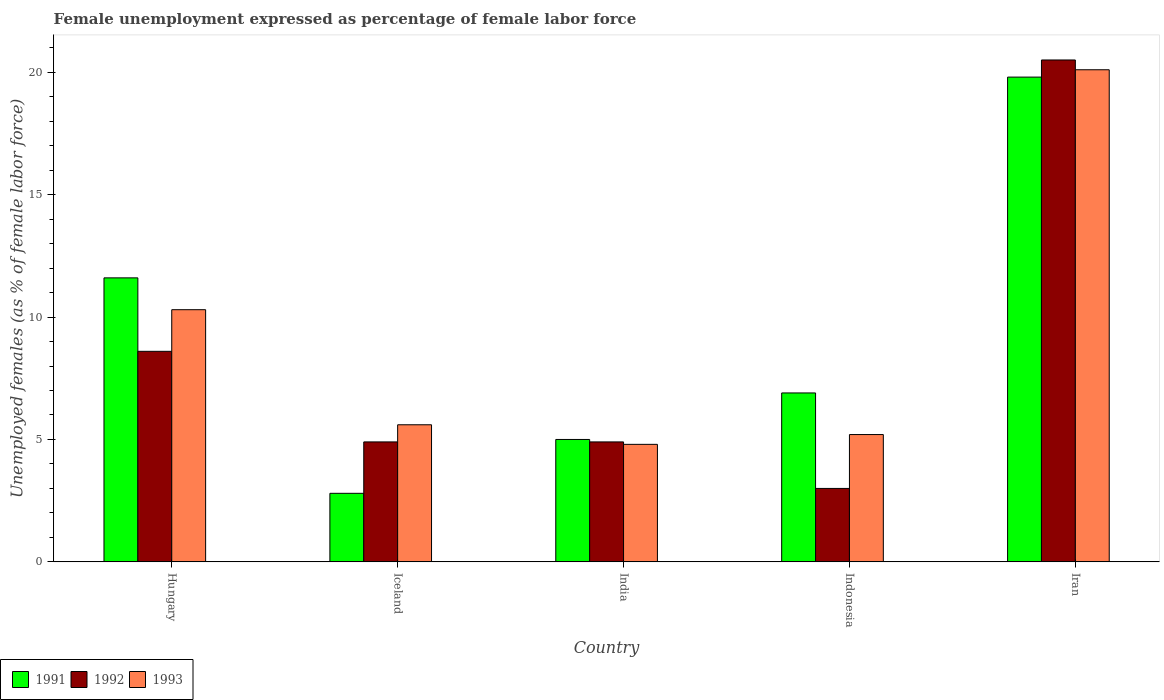How many groups of bars are there?
Your answer should be very brief. 5. How many bars are there on the 1st tick from the left?
Your response must be concise. 3. How many bars are there on the 3rd tick from the right?
Keep it short and to the point. 3. What is the label of the 5th group of bars from the left?
Offer a terse response. Iran. What is the unemployment in females in in 1992 in Hungary?
Your answer should be very brief. 8.6. Across all countries, what is the maximum unemployment in females in in 1991?
Your answer should be very brief. 19.8. Across all countries, what is the minimum unemployment in females in in 1993?
Offer a very short reply. 4.8. In which country was the unemployment in females in in 1992 maximum?
Offer a terse response. Iran. What is the total unemployment in females in in 1991 in the graph?
Your answer should be very brief. 46.1. What is the difference between the unemployment in females in in 1992 in India and that in Indonesia?
Offer a very short reply. 1.9. What is the difference between the unemployment in females in in 1992 in India and the unemployment in females in in 1991 in Hungary?
Your answer should be compact. -6.7. What is the average unemployment in females in in 1992 per country?
Offer a very short reply. 8.38. What is the difference between the unemployment in females in of/in 1991 and unemployment in females in of/in 1992 in Hungary?
Give a very brief answer. 3. In how many countries, is the unemployment in females in in 1992 greater than 3 %?
Ensure brevity in your answer.  4. What is the ratio of the unemployment in females in in 1992 in Iceland to that in Iran?
Provide a succinct answer. 0.24. Is the difference between the unemployment in females in in 1991 in Hungary and India greater than the difference between the unemployment in females in in 1992 in Hungary and India?
Your answer should be very brief. Yes. What is the difference between the highest and the second highest unemployment in females in in 1993?
Your response must be concise. -9.8. What is the difference between the highest and the lowest unemployment in females in in 1992?
Your response must be concise. 17.5. In how many countries, is the unemployment in females in in 1991 greater than the average unemployment in females in in 1991 taken over all countries?
Ensure brevity in your answer.  2. How many countries are there in the graph?
Offer a very short reply. 5. Are the values on the major ticks of Y-axis written in scientific E-notation?
Make the answer very short. No. Does the graph contain any zero values?
Provide a succinct answer. No. How many legend labels are there?
Your answer should be very brief. 3. How are the legend labels stacked?
Keep it short and to the point. Horizontal. What is the title of the graph?
Offer a terse response. Female unemployment expressed as percentage of female labor force. What is the label or title of the Y-axis?
Your response must be concise. Unemployed females (as % of female labor force). What is the Unemployed females (as % of female labor force) in 1991 in Hungary?
Your answer should be very brief. 11.6. What is the Unemployed females (as % of female labor force) in 1992 in Hungary?
Make the answer very short. 8.6. What is the Unemployed females (as % of female labor force) of 1993 in Hungary?
Provide a succinct answer. 10.3. What is the Unemployed females (as % of female labor force) of 1991 in Iceland?
Your answer should be very brief. 2.8. What is the Unemployed females (as % of female labor force) in 1992 in Iceland?
Offer a terse response. 4.9. What is the Unemployed females (as % of female labor force) in 1993 in Iceland?
Keep it short and to the point. 5.6. What is the Unemployed females (as % of female labor force) in 1992 in India?
Offer a terse response. 4.9. What is the Unemployed females (as % of female labor force) of 1993 in India?
Your answer should be compact. 4.8. What is the Unemployed females (as % of female labor force) of 1991 in Indonesia?
Offer a terse response. 6.9. What is the Unemployed females (as % of female labor force) in 1992 in Indonesia?
Your answer should be very brief. 3. What is the Unemployed females (as % of female labor force) in 1993 in Indonesia?
Offer a terse response. 5.2. What is the Unemployed females (as % of female labor force) in 1991 in Iran?
Your answer should be very brief. 19.8. What is the Unemployed females (as % of female labor force) of 1992 in Iran?
Give a very brief answer. 20.5. What is the Unemployed females (as % of female labor force) in 1993 in Iran?
Ensure brevity in your answer.  20.1. Across all countries, what is the maximum Unemployed females (as % of female labor force) of 1991?
Make the answer very short. 19.8. Across all countries, what is the maximum Unemployed females (as % of female labor force) in 1992?
Your answer should be very brief. 20.5. Across all countries, what is the maximum Unemployed females (as % of female labor force) of 1993?
Make the answer very short. 20.1. Across all countries, what is the minimum Unemployed females (as % of female labor force) of 1991?
Your response must be concise. 2.8. Across all countries, what is the minimum Unemployed females (as % of female labor force) in 1993?
Offer a terse response. 4.8. What is the total Unemployed females (as % of female labor force) in 1991 in the graph?
Keep it short and to the point. 46.1. What is the total Unemployed females (as % of female labor force) of 1992 in the graph?
Make the answer very short. 41.9. What is the total Unemployed females (as % of female labor force) in 1993 in the graph?
Provide a succinct answer. 46. What is the difference between the Unemployed females (as % of female labor force) of 1992 in Hungary and that in Iceland?
Ensure brevity in your answer.  3.7. What is the difference between the Unemployed females (as % of female labor force) in 1993 in Hungary and that in Iceland?
Offer a very short reply. 4.7. What is the difference between the Unemployed females (as % of female labor force) of 1991 in Hungary and that in India?
Offer a very short reply. 6.6. What is the difference between the Unemployed females (as % of female labor force) of 1991 in Hungary and that in Iran?
Provide a short and direct response. -8.2. What is the difference between the Unemployed females (as % of female labor force) in 1992 in Hungary and that in Iran?
Provide a succinct answer. -11.9. What is the difference between the Unemployed females (as % of female labor force) of 1993 in Hungary and that in Iran?
Provide a succinct answer. -9.8. What is the difference between the Unemployed females (as % of female labor force) of 1991 in Iceland and that in India?
Offer a terse response. -2.2. What is the difference between the Unemployed females (as % of female labor force) in 1993 in Iceland and that in India?
Ensure brevity in your answer.  0.8. What is the difference between the Unemployed females (as % of female labor force) of 1991 in Iceland and that in Indonesia?
Provide a short and direct response. -4.1. What is the difference between the Unemployed females (as % of female labor force) in 1991 in Iceland and that in Iran?
Ensure brevity in your answer.  -17. What is the difference between the Unemployed females (as % of female labor force) in 1992 in Iceland and that in Iran?
Your answer should be very brief. -15.6. What is the difference between the Unemployed females (as % of female labor force) in 1993 in Iceland and that in Iran?
Your response must be concise. -14.5. What is the difference between the Unemployed females (as % of female labor force) in 1992 in India and that in Indonesia?
Your answer should be compact. 1.9. What is the difference between the Unemployed females (as % of female labor force) of 1991 in India and that in Iran?
Keep it short and to the point. -14.8. What is the difference between the Unemployed females (as % of female labor force) in 1992 in India and that in Iran?
Offer a terse response. -15.6. What is the difference between the Unemployed females (as % of female labor force) of 1993 in India and that in Iran?
Your response must be concise. -15.3. What is the difference between the Unemployed females (as % of female labor force) of 1991 in Indonesia and that in Iran?
Offer a terse response. -12.9. What is the difference between the Unemployed females (as % of female labor force) of 1992 in Indonesia and that in Iran?
Offer a terse response. -17.5. What is the difference between the Unemployed females (as % of female labor force) of 1993 in Indonesia and that in Iran?
Give a very brief answer. -14.9. What is the difference between the Unemployed females (as % of female labor force) in 1992 in Hungary and the Unemployed females (as % of female labor force) in 1993 in Iceland?
Give a very brief answer. 3. What is the difference between the Unemployed females (as % of female labor force) in 1991 in Hungary and the Unemployed females (as % of female labor force) in 1992 in India?
Your response must be concise. 6.7. What is the difference between the Unemployed females (as % of female labor force) of 1991 in Hungary and the Unemployed females (as % of female labor force) of 1993 in India?
Ensure brevity in your answer.  6.8. What is the difference between the Unemployed females (as % of female labor force) in 1992 in Hungary and the Unemployed females (as % of female labor force) in 1993 in India?
Your response must be concise. 3.8. What is the difference between the Unemployed females (as % of female labor force) of 1991 in Hungary and the Unemployed females (as % of female labor force) of 1992 in Indonesia?
Make the answer very short. 8.6. What is the difference between the Unemployed females (as % of female labor force) in 1992 in Hungary and the Unemployed females (as % of female labor force) in 1993 in Indonesia?
Keep it short and to the point. 3.4. What is the difference between the Unemployed females (as % of female labor force) of 1991 in Hungary and the Unemployed females (as % of female labor force) of 1992 in Iran?
Your answer should be very brief. -8.9. What is the difference between the Unemployed females (as % of female labor force) in 1991 in Hungary and the Unemployed females (as % of female labor force) in 1993 in Iran?
Your answer should be very brief. -8.5. What is the difference between the Unemployed females (as % of female labor force) in 1991 in Iceland and the Unemployed females (as % of female labor force) in 1992 in India?
Offer a very short reply. -2.1. What is the difference between the Unemployed females (as % of female labor force) in 1991 in Iceland and the Unemployed females (as % of female labor force) in 1992 in Indonesia?
Offer a terse response. -0.2. What is the difference between the Unemployed females (as % of female labor force) of 1991 in Iceland and the Unemployed females (as % of female labor force) of 1993 in Indonesia?
Provide a succinct answer. -2.4. What is the difference between the Unemployed females (as % of female labor force) in 1992 in Iceland and the Unemployed females (as % of female labor force) in 1993 in Indonesia?
Your answer should be compact. -0.3. What is the difference between the Unemployed females (as % of female labor force) of 1991 in Iceland and the Unemployed females (as % of female labor force) of 1992 in Iran?
Your answer should be very brief. -17.7. What is the difference between the Unemployed females (as % of female labor force) in 1991 in Iceland and the Unemployed females (as % of female labor force) in 1993 in Iran?
Provide a short and direct response. -17.3. What is the difference between the Unemployed females (as % of female labor force) in 1992 in Iceland and the Unemployed females (as % of female labor force) in 1993 in Iran?
Your response must be concise. -15.2. What is the difference between the Unemployed females (as % of female labor force) in 1991 in India and the Unemployed females (as % of female labor force) in 1992 in Indonesia?
Give a very brief answer. 2. What is the difference between the Unemployed females (as % of female labor force) in 1991 in India and the Unemployed females (as % of female labor force) in 1993 in Indonesia?
Give a very brief answer. -0.2. What is the difference between the Unemployed females (as % of female labor force) in 1991 in India and the Unemployed females (as % of female labor force) in 1992 in Iran?
Your response must be concise. -15.5. What is the difference between the Unemployed females (as % of female labor force) of 1991 in India and the Unemployed females (as % of female labor force) of 1993 in Iran?
Provide a succinct answer. -15.1. What is the difference between the Unemployed females (as % of female labor force) in 1992 in India and the Unemployed females (as % of female labor force) in 1993 in Iran?
Make the answer very short. -15.2. What is the difference between the Unemployed females (as % of female labor force) in 1992 in Indonesia and the Unemployed females (as % of female labor force) in 1993 in Iran?
Offer a terse response. -17.1. What is the average Unemployed females (as % of female labor force) in 1991 per country?
Your response must be concise. 9.22. What is the average Unemployed females (as % of female labor force) in 1992 per country?
Make the answer very short. 8.38. What is the difference between the Unemployed females (as % of female labor force) in 1992 and Unemployed females (as % of female labor force) in 1993 in Hungary?
Offer a very short reply. -1.7. What is the difference between the Unemployed females (as % of female labor force) of 1991 and Unemployed females (as % of female labor force) of 1992 in Iceland?
Keep it short and to the point. -2.1. What is the difference between the Unemployed females (as % of female labor force) of 1992 and Unemployed females (as % of female labor force) of 1993 in Iceland?
Your answer should be compact. -0.7. What is the difference between the Unemployed females (as % of female labor force) in 1992 and Unemployed females (as % of female labor force) in 1993 in India?
Ensure brevity in your answer.  0.1. What is the difference between the Unemployed females (as % of female labor force) of 1991 and Unemployed females (as % of female labor force) of 1993 in Indonesia?
Give a very brief answer. 1.7. What is the difference between the Unemployed females (as % of female labor force) of 1991 and Unemployed females (as % of female labor force) of 1992 in Iran?
Make the answer very short. -0.7. What is the difference between the Unemployed females (as % of female labor force) of 1991 and Unemployed females (as % of female labor force) of 1993 in Iran?
Your answer should be very brief. -0.3. What is the ratio of the Unemployed females (as % of female labor force) of 1991 in Hungary to that in Iceland?
Keep it short and to the point. 4.14. What is the ratio of the Unemployed females (as % of female labor force) in 1992 in Hungary to that in Iceland?
Your answer should be very brief. 1.76. What is the ratio of the Unemployed females (as % of female labor force) in 1993 in Hungary to that in Iceland?
Your response must be concise. 1.84. What is the ratio of the Unemployed females (as % of female labor force) of 1991 in Hungary to that in India?
Keep it short and to the point. 2.32. What is the ratio of the Unemployed females (as % of female labor force) in 1992 in Hungary to that in India?
Offer a terse response. 1.76. What is the ratio of the Unemployed females (as % of female labor force) of 1993 in Hungary to that in India?
Give a very brief answer. 2.15. What is the ratio of the Unemployed females (as % of female labor force) of 1991 in Hungary to that in Indonesia?
Make the answer very short. 1.68. What is the ratio of the Unemployed females (as % of female labor force) of 1992 in Hungary to that in Indonesia?
Give a very brief answer. 2.87. What is the ratio of the Unemployed females (as % of female labor force) in 1993 in Hungary to that in Indonesia?
Give a very brief answer. 1.98. What is the ratio of the Unemployed females (as % of female labor force) of 1991 in Hungary to that in Iran?
Give a very brief answer. 0.59. What is the ratio of the Unemployed females (as % of female labor force) in 1992 in Hungary to that in Iran?
Your answer should be compact. 0.42. What is the ratio of the Unemployed females (as % of female labor force) in 1993 in Hungary to that in Iran?
Provide a short and direct response. 0.51. What is the ratio of the Unemployed females (as % of female labor force) of 1991 in Iceland to that in India?
Keep it short and to the point. 0.56. What is the ratio of the Unemployed females (as % of female labor force) of 1992 in Iceland to that in India?
Your answer should be compact. 1. What is the ratio of the Unemployed females (as % of female labor force) in 1991 in Iceland to that in Indonesia?
Offer a very short reply. 0.41. What is the ratio of the Unemployed females (as % of female labor force) in 1992 in Iceland to that in Indonesia?
Keep it short and to the point. 1.63. What is the ratio of the Unemployed females (as % of female labor force) of 1991 in Iceland to that in Iran?
Ensure brevity in your answer.  0.14. What is the ratio of the Unemployed females (as % of female labor force) of 1992 in Iceland to that in Iran?
Provide a succinct answer. 0.24. What is the ratio of the Unemployed females (as % of female labor force) of 1993 in Iceland to that in Iran?
Offer a very short reply. 0.28. What is the ratio of the Unemployed females (as % of female labor force) in 1991 in India to that in Indonesia?
Offer a very short reply. 0.72. What is the ratio of the Unemployed females (as % of female labor force) of 1992 in India to that in Indonesia?
Provide a short and direct response. 1.63. What is the ratio of the Unemployed females (as % of female labor force) of 1993 in India to that in Indonesia?
Provide a succinct answer. 0.92. What is the ratio of the Unemployed females (as % of female labor force) in 1991 in India to that in Iran?
Keep it short and to the point. 0.25. What is the ratio of the Unemployed females (as % of female labor force) in 1992 in India to that in Iran?
Your answer should be very brief. 0.24. What is the ratio of the Unemployed females (as % of female labor force) of 1993 in India to that in Iran?
Offer a very short reply. 0.24. What is the ratio of the Unemployed females (as % of female labor force) in 1991 in Indonesia to that in Iran?
Your answer should be very brief. 0.35. What is the ratio of the Unemployed females (as % of female labor force) of 1992 in Indonesia to that in Iran?
Ensure brevity in your answer.  0.15. What is the ratio of the Unemployed females (as % of female labor force) in 1993 in Indonesia to that in Iran?
Offer a terse response. 0.26. What is the difference between the highest and the lowest Unemployed females (as % of female labor force) in 1991?
Your response must be concise. 17. What is the difference between the highest and the lowest Unemployed females (as % of female labor force) in 1992?
Your answer should be compact. 17.5. What is the difference between the highest and the lowest Unemployed females (as % of female labor force) in 1993?
Provide a succinct answer. 15.3. 